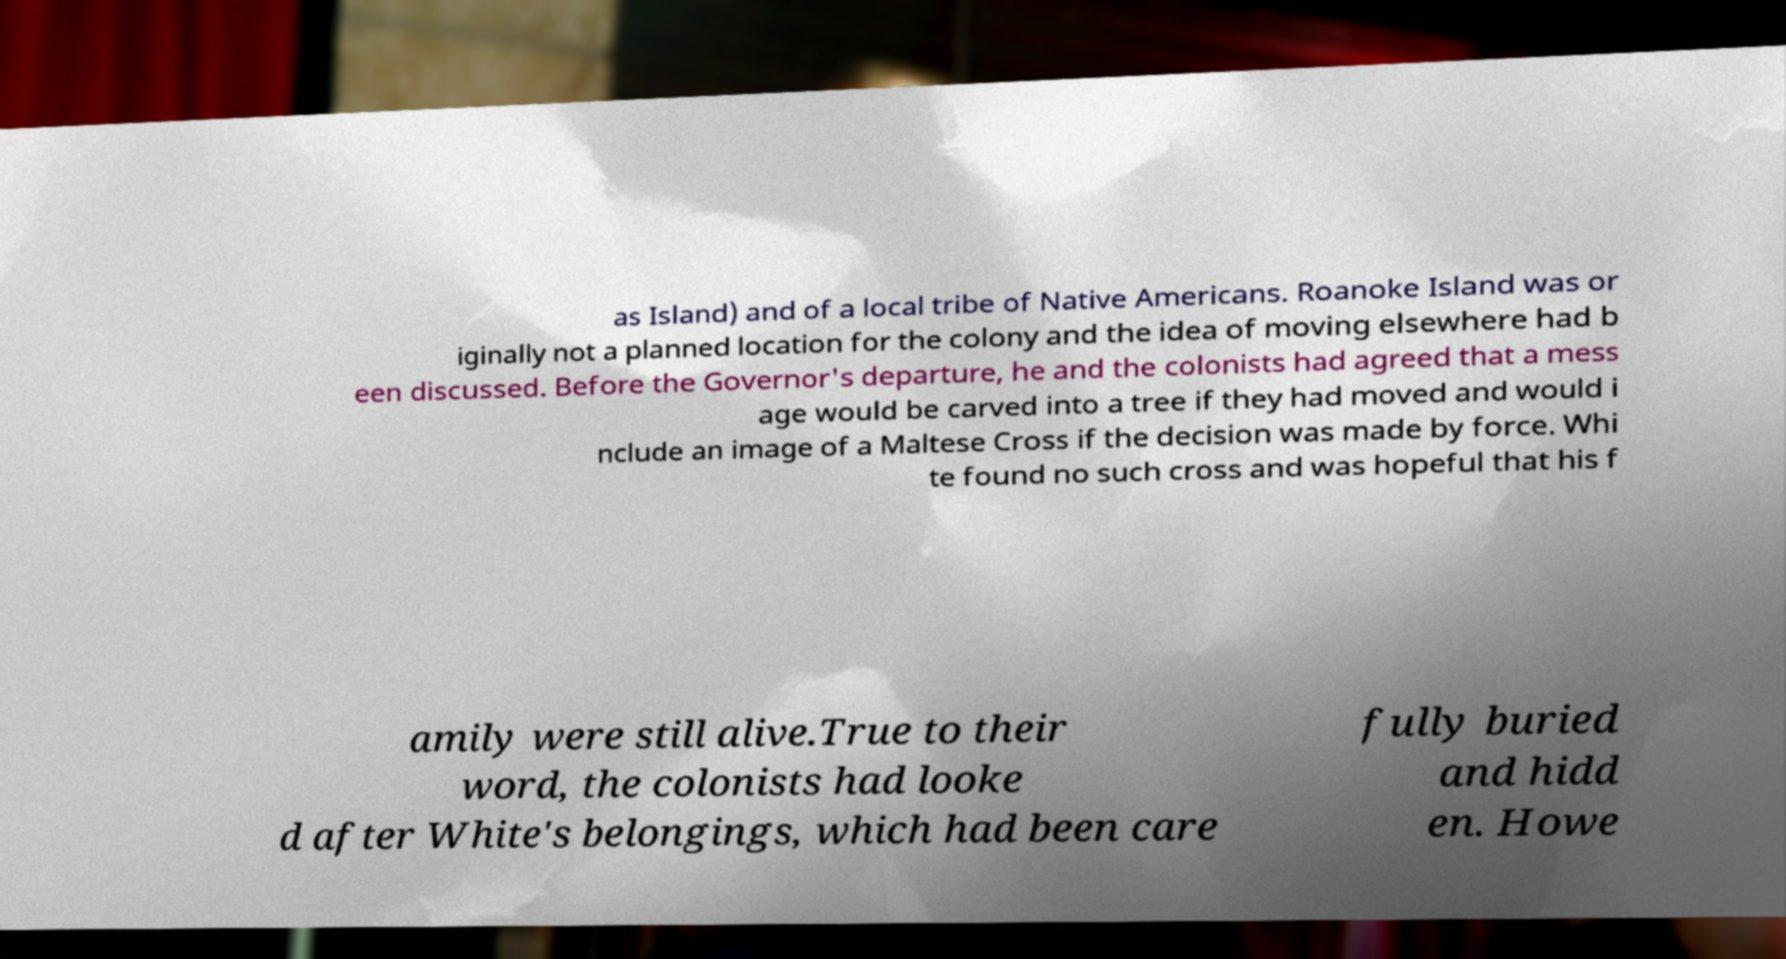Can you read and provide the text displayed in the image?This photo seems to have some interesting text. Can you extract and type it out for me? as Island) and of a local tribe of Native Americans. Roanoke Island was or iginally not a planned location for the colony and the idea of moving elsewhere had b een discussed. Before the Governor's departure, he and the colonists had agreed that a mess age would be carved into a tree if they had moved and would i nclude an image of a Maltese Cross if the decision was made by force. Whi te found no such cross and was hopeful that his f amily were still alive.True to their word, the colonists had looke d after White's belongings, which had been care fully buried and hidd en. Howe 